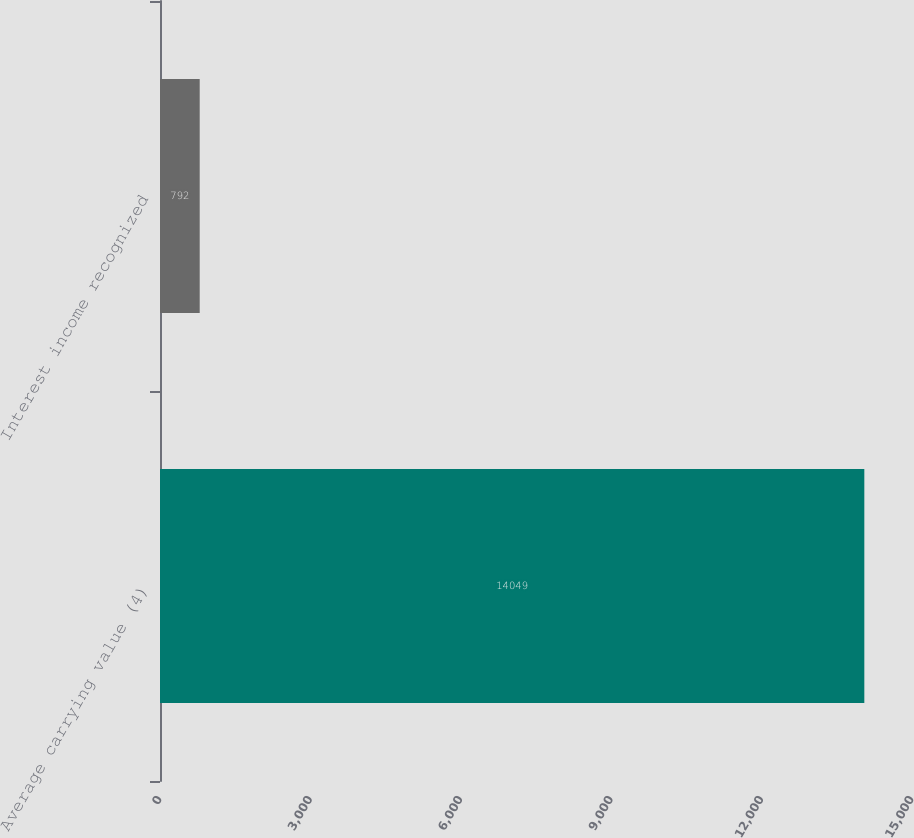Convert chart. <chart><loc_0><loc_0><loc_500><loc_500><bar_chart><fcel>Average carrying value (4)<fcel>Interest income recognized<nl><fcel>14049<fcel>792<nl></chart> 